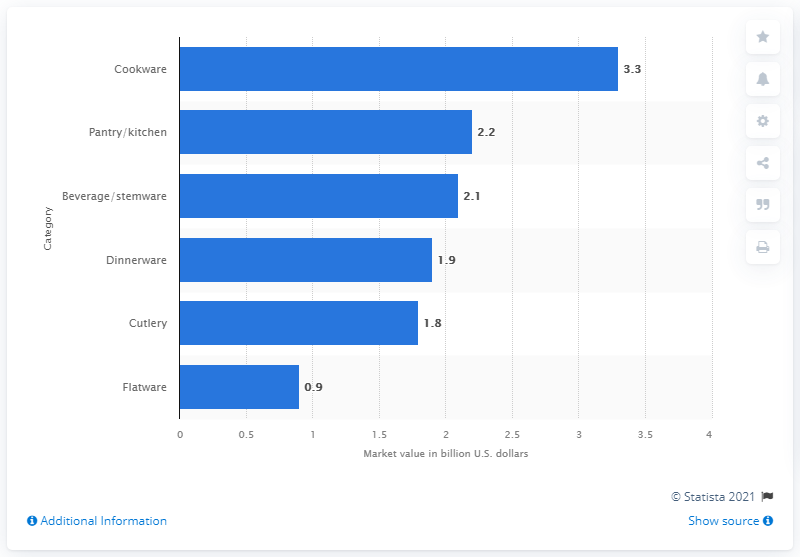Highlight a few significant elements in this photo. The value of the dinnerware market in the US as of 2012 was estimated to be 1.9 billion dollars. In 2012, the U.S. tabletop market generated $3.3 billion in revenue from the sale of cookware. The sum value of the top two categories of the US Tableware market in 2012 was approximately $5.5 billion. 